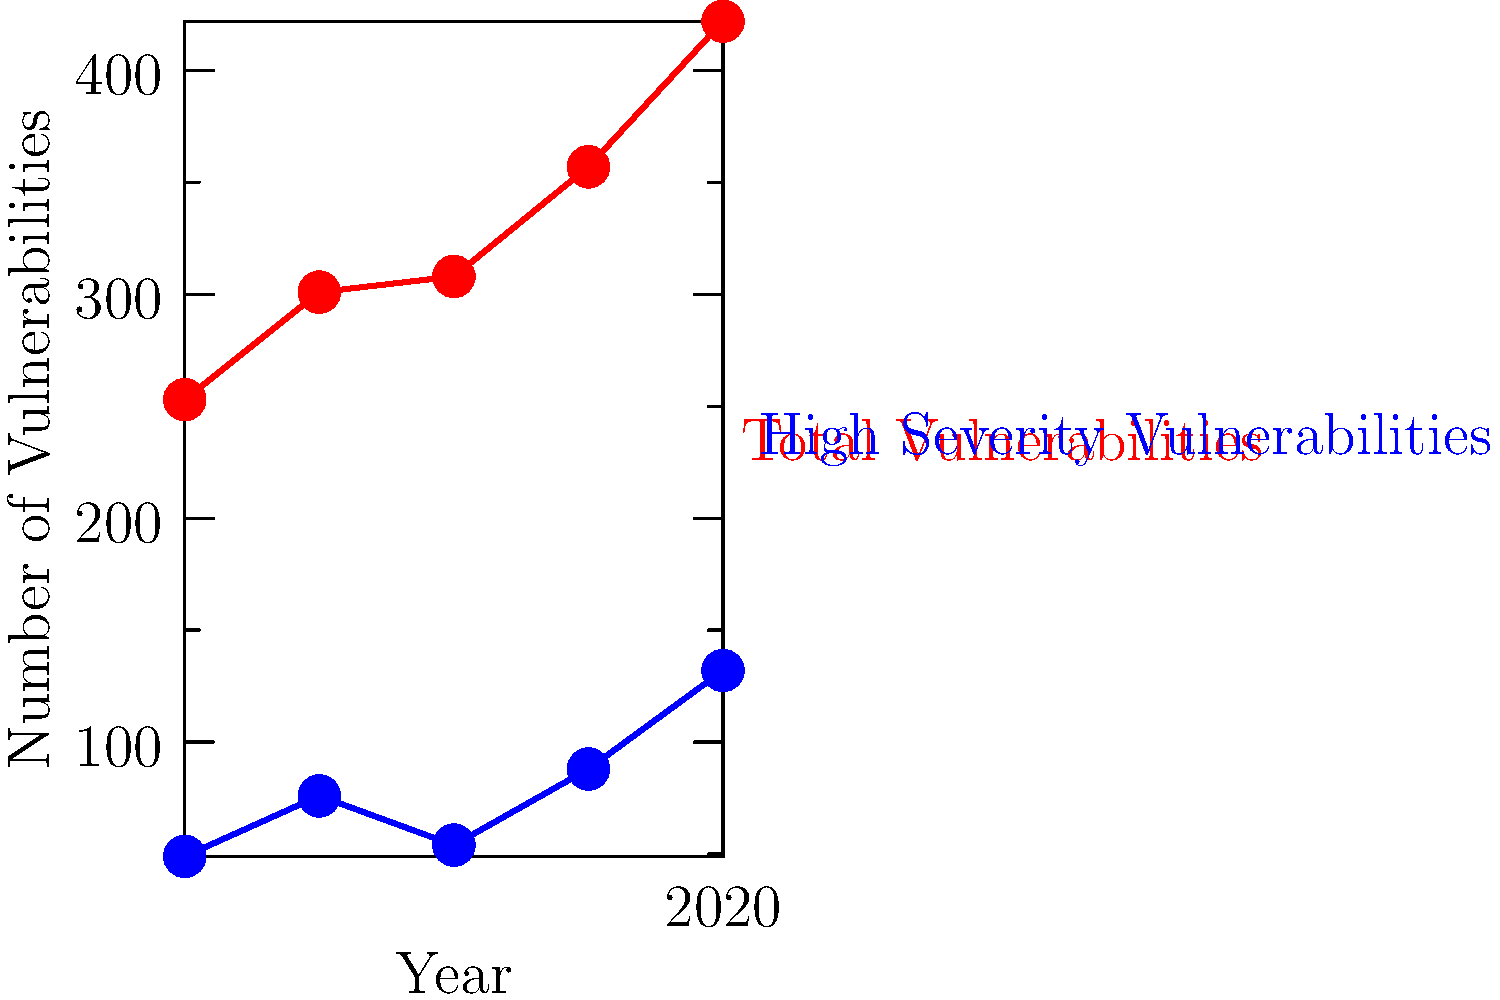Based on the graph showing Windows 10 security vulnerabilities from 2016 to 2020, calculate the percentage increase in high severity vulnerabilities from 2019 to 2020. How does this compare to the overall trend, and what implications might this have for Windows 10 users and Microsoft's security team? To answer this question, we need to follow these steps:

1. Identify the number of high severity vulnerabilities in 2019 and 2020:
   2019: 88
   2020: 132

2. Calculate the percentage increase:
   Percentage increase = (New value - Original value) / Original value * 100
   = (132 - 88) / 88 * 100
   = 44 / 88 * 100
   = 0.5 * 100
   = 50%

3. Analyze the overall trend:
   - Total vulnerabilities have been steadily increasing each year.
   - High severity vulnerabilities have also generally increased, but with some fluctuations.

4. Compare the 2019-2020 increase to the overall trend:
   The 50% increase in high severity vulnerabilities from 2019 to 2020 is more dramatic than the general trend, indicating a significant spike in serious security issues.

5. Implications for Windows 10 users and Microsoft's security team:
   a) Users need to be more vigilant about applying security updates promptly.
   b) There may be an increased risk of exploitation of these vulnerabilities.
   c) Microsoft's security team likely needs to allocate more resources to address and mitigate these high severity issues.
   d) The trend suggests that the Windows 10 codebase may be becoming more complex or that attackers are finding more sophisticated ways to exploit it.
   e) Microsoft may need to consider more frequent or comprehensive security audits of their codebase.
Answer: 50% increase; significantly higher than the overall trend, indicating increased security risks and the need for more robust security measures. 